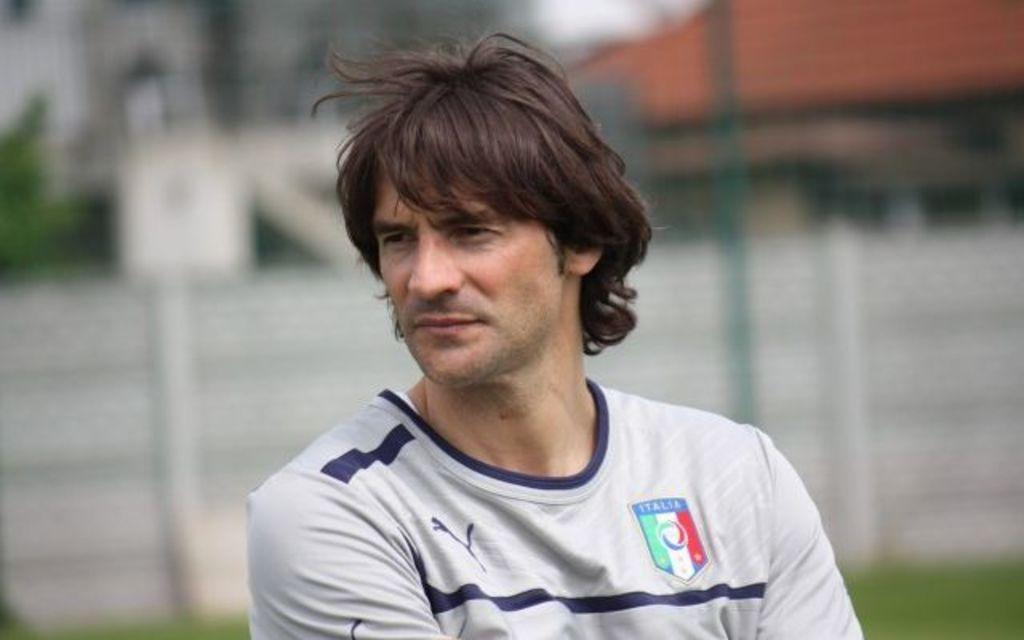Provide a one-sentence caption for the provided image. A player wears a white jersey with an emblem that says Italia on it. 